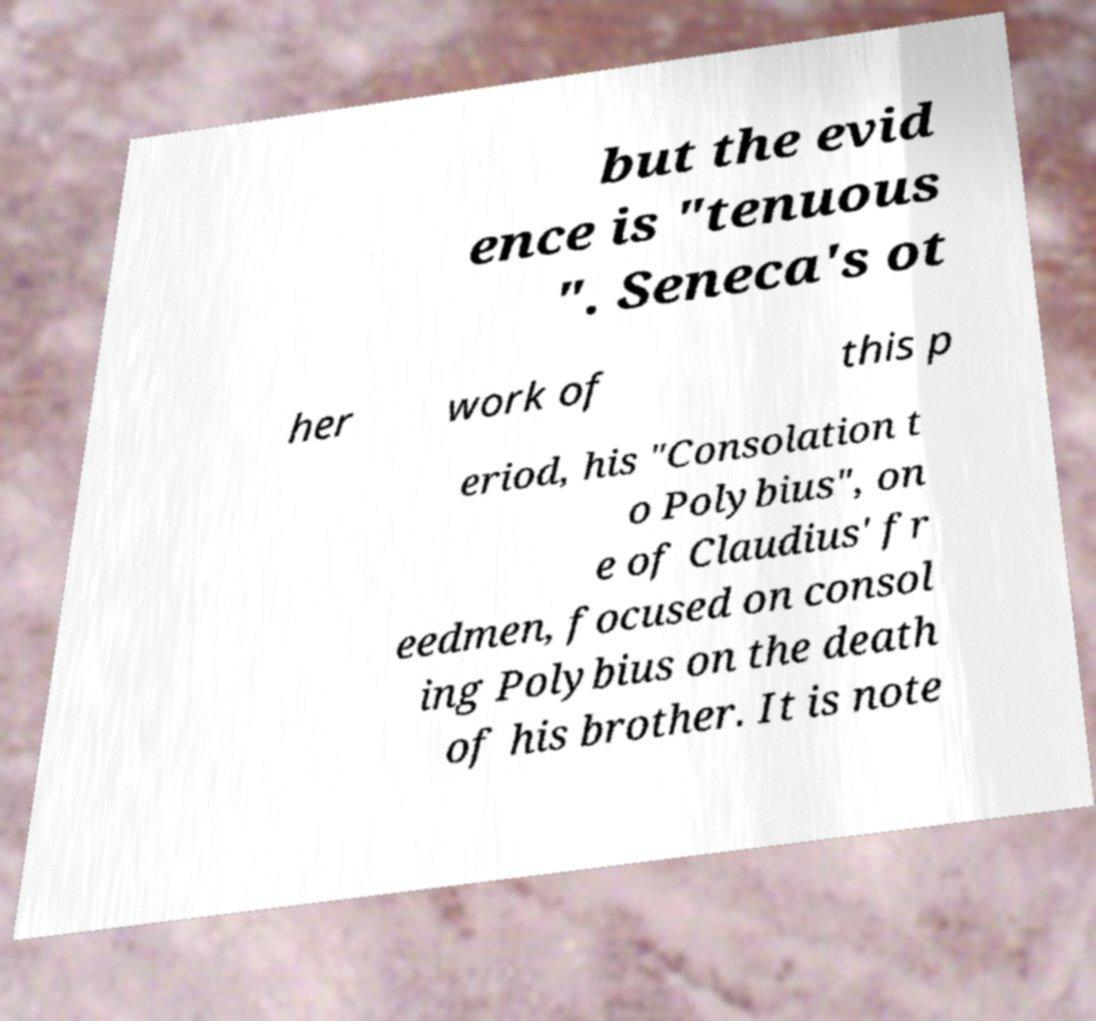Could you extract and type out the text from this image? but the evid ence is "tenuous ". Seneca's ot her work of this p eriod, his "Consolation t o Polybius", on e of Claudius' fr eedmen, focused on consol ing Polybius on the death of his brother. It is note 